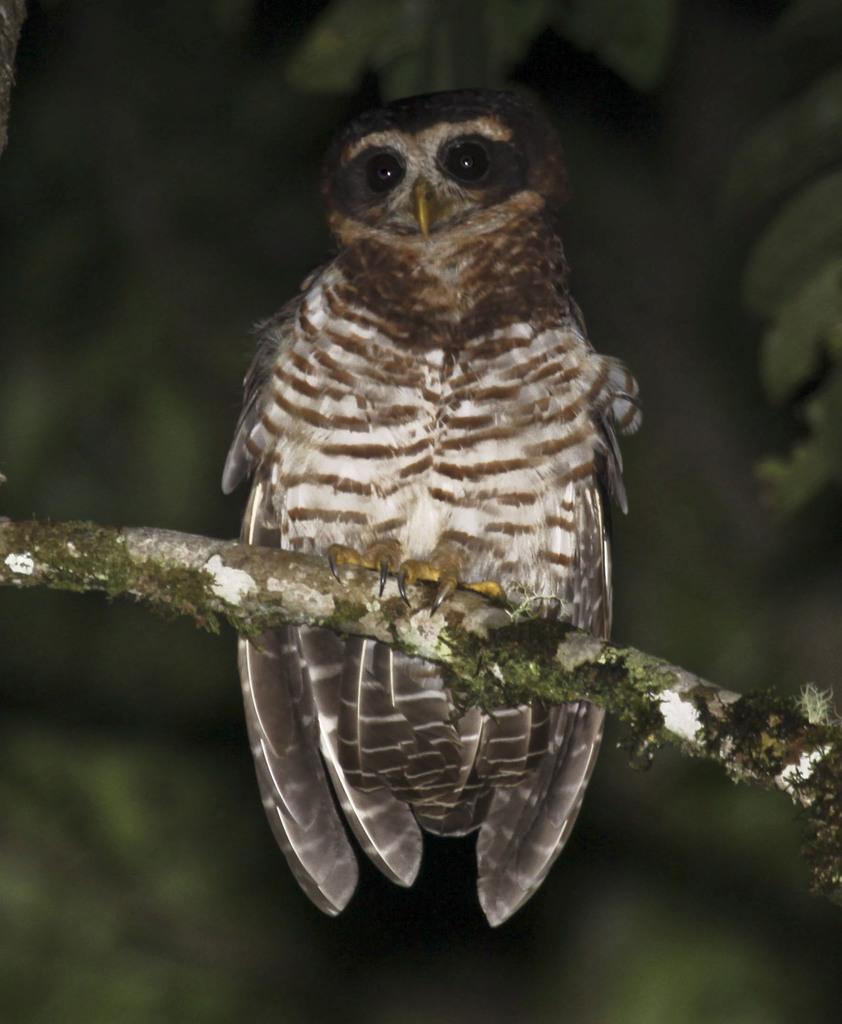Could you give a brief overview of what you see in this image? In this image there is an owl sitting on the stem. The background is blurry. 